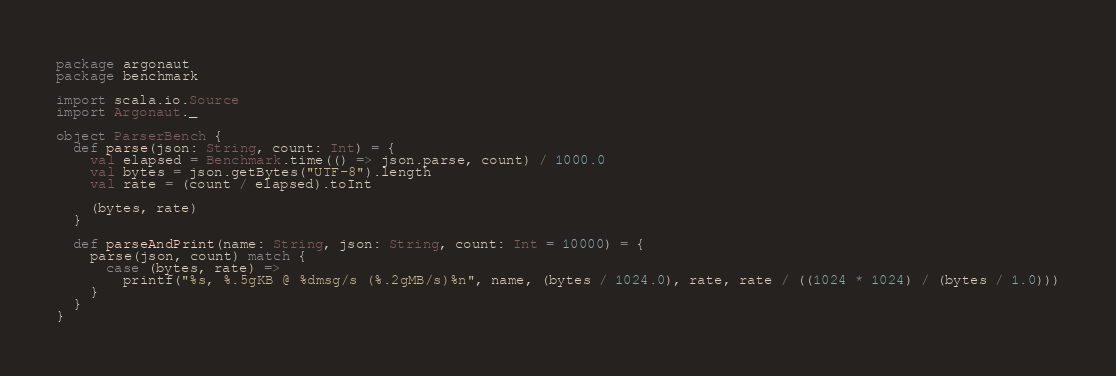Convert code to text. <code><loc_0><loc_0><loc_500><loc_500><_Scala_>package argonaut
package benchmark

import scala.io.Source
import Argonaut._

object ParserBench {
  def parse(json: String, count: Int) = {
    val elapsed = Benchmark.time(() => json.parse, count) / 1000.0
    val bytes = json.getBytes("UTF-8").length
    val rate = (count / elapsed).toInt

    (bytes, rate)
  }

  def parseAndPrint(name: String, json: String, count: Int = 10000) = {
    parse(json, count) match {
      case (bytes, rate) =>
        printf("%s, %.5gKB @ %dmsg/s (%.2gMB/s)%n", name, (bytes / 1024.0), rate, rate / ((1024 * 1024) / (bytes / 1.0)))
    }
  }
}
</code> 